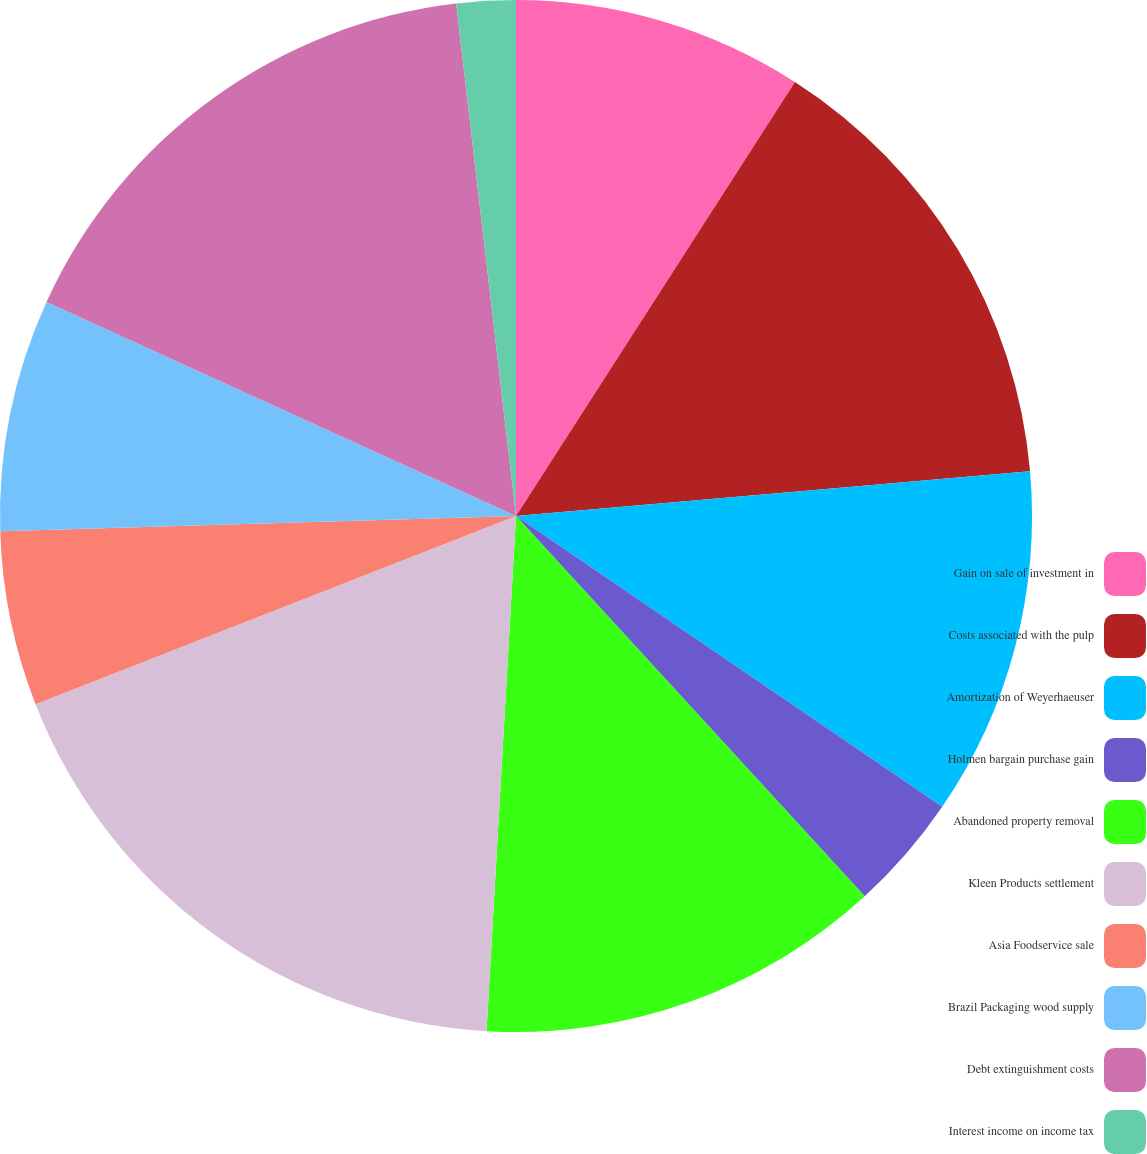Convert chart. <chart><loc_0><loc_0><loc_500><loc_500><pie_chart><fcel>Gain on sale of investment in<fcel>Costs associated with the pulp<fcel>Amortization of Weyerhaeuser<fcel>Holmen bargain purchase gain<fcel>Abandoned property removal<fcel>Kleen Products settlement<fcel>Asia Foodservice sale<fcel>Brazil Packaging wood supply<fcel>Debt extinguishment costs<fcel>Interest income on income tax<nl><fcel>9.09%<fcel>14.53%<fcel>10.91%<fcel>3.66%<fcel>12.72%<fcel>18.15%<fcel>5.47%<fcel>7.28%<fcel>16.34%<fcel>1.85%<nl></chart> 